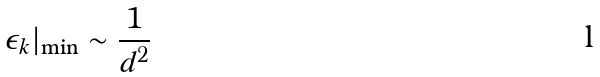Convert formula to latex. <formula><loc_0><loc_0><loc_500><loc_500>\epsilon _ { k } | _ { \min } \sim \frac { 1 } { d ^ { 2 } }</formula> 